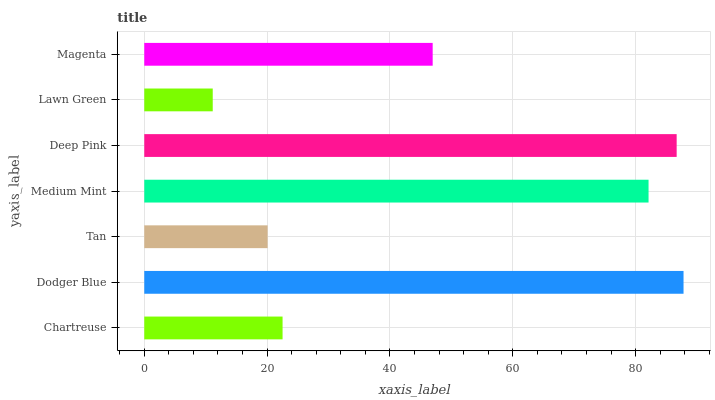Is Lawn Green the minimum?
Answer yes or no. Yes. Is Dodger Blue the maximum?
Answer yes or no. Yes. Is Tan the minimum?
Answer yes or no. No. Is Tan the maximum?
Answer yes or no. No. Is Dodger Blue greater than Tan?
Answer yes or no. Yes. Is Tan less than Dodger Blue?
Answer yes or no. Yes. Is Tan greater than Dodger Blue?
Answer yes or no. No. Is Dodger Blue less than Tan?
Answer yes or no. No. Is Magenta the high median?
Answer yes or no. Yes. Is Magenta the low median?
Answer yes or no. Yes. Is Tan the high median?
Answer yes or no. No. Is Tan the low median?
Answer yes or no. No. 